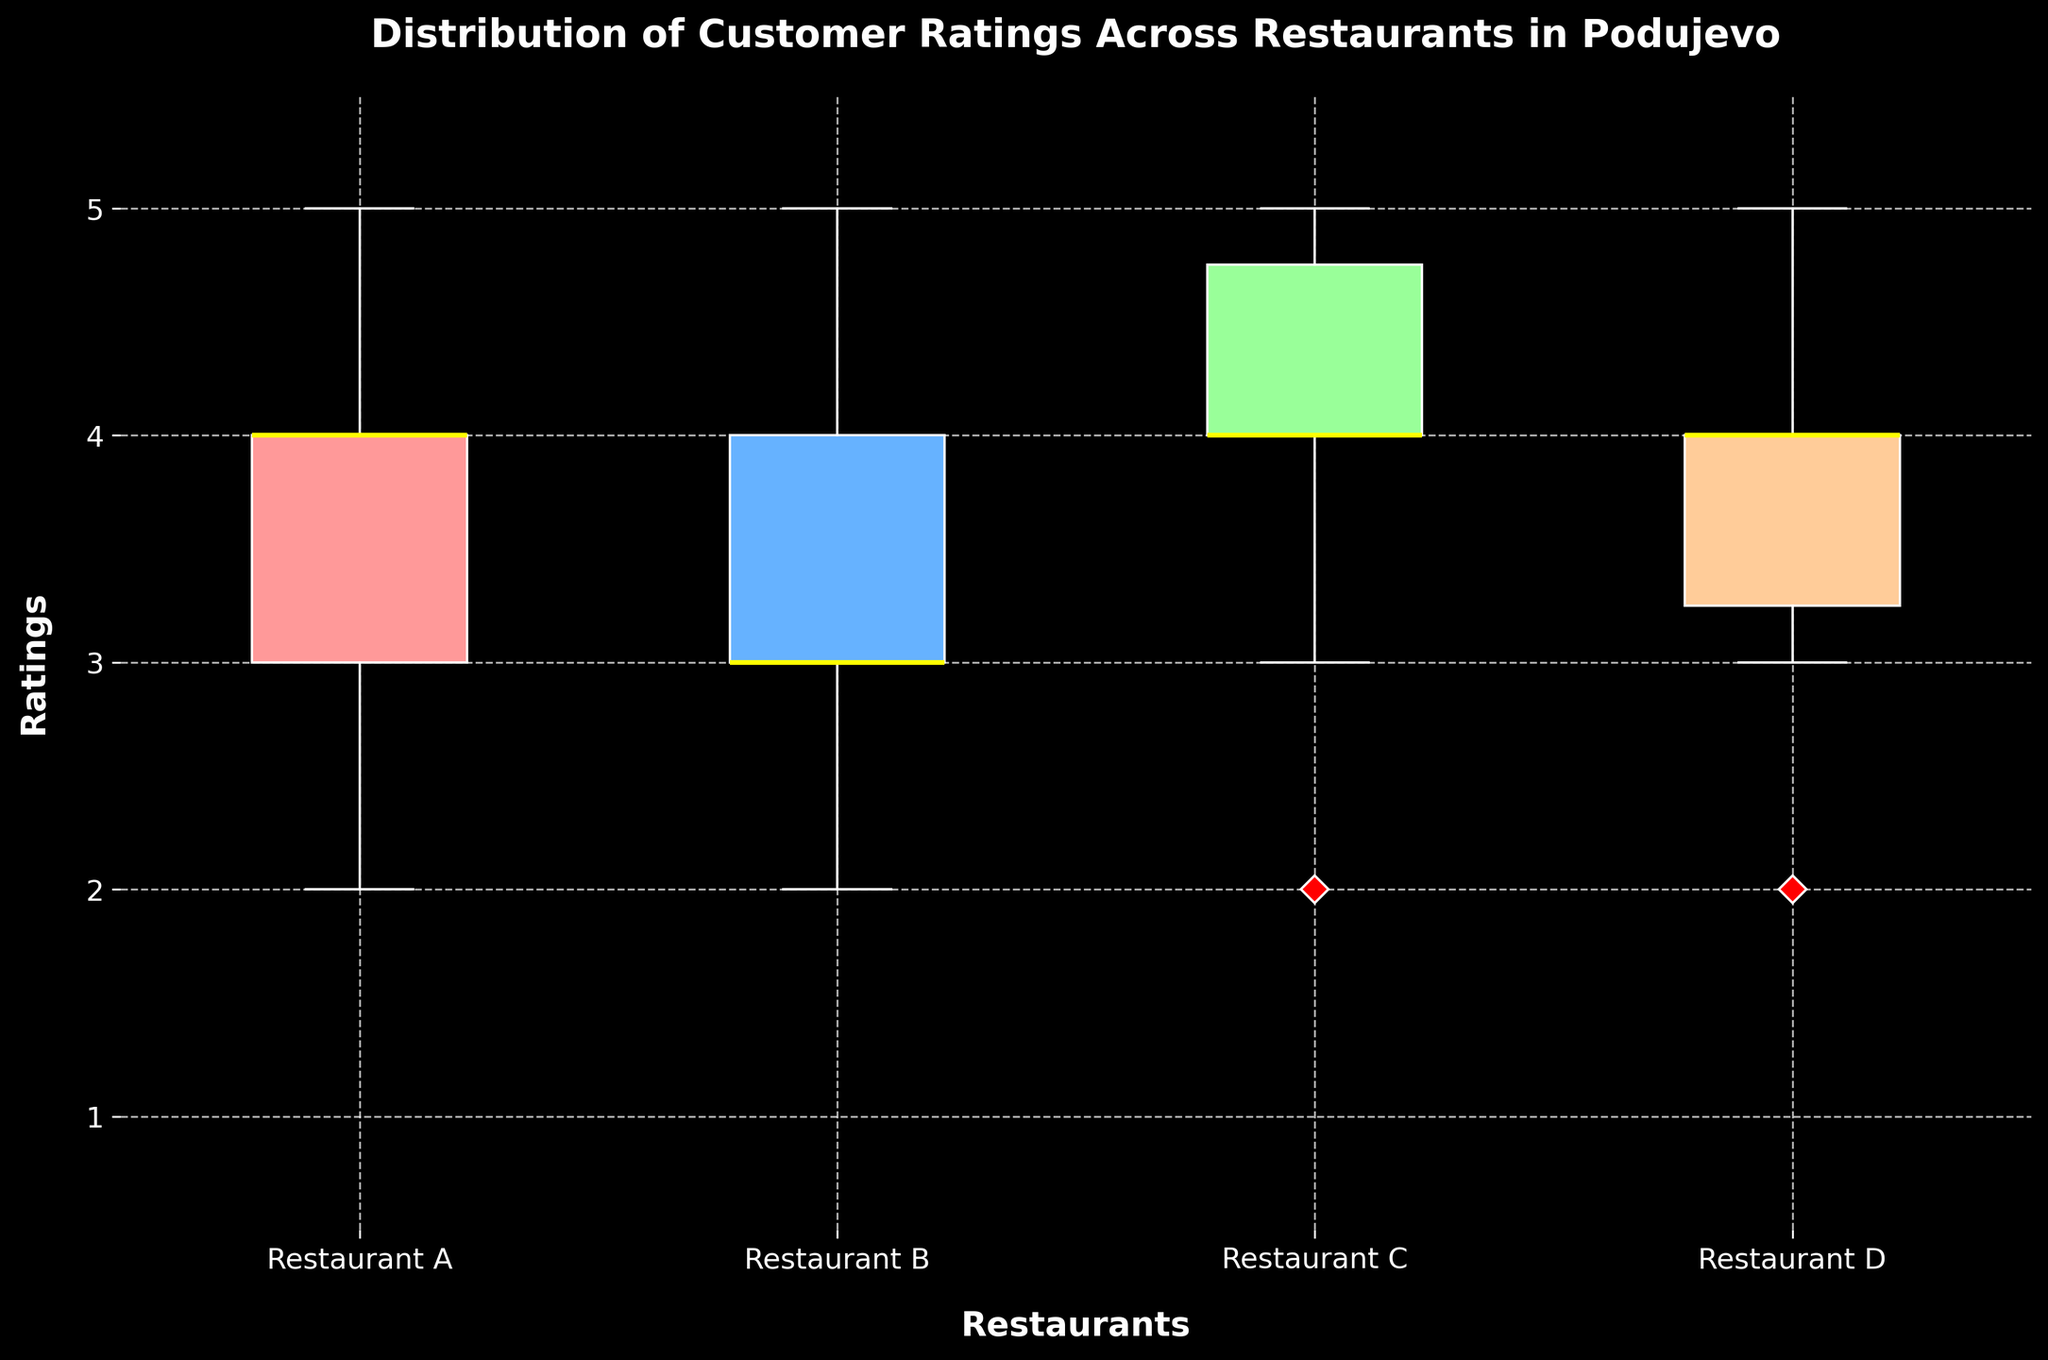What is the title of the plot? The title is found at the top of the plot and summarizes what the figure represents. The title given is 'Distribution of Customer Ratings Across Restaurants in Podujevo'.
Answer: Distribution of Customer Ratings Across Restaurants in Podujevo Which restaurant has the highest median rating? To identify the highest median rating, look for the restaurant with the median line (usually in the middle of the box) at the highest point. In this case, Restaurant C has the highest median rating.
Answer: Restaurant C What are the colors of the boxes in the plot? Each restaurant's box plot is colored differently. The colors used are light pink, light blue, light green, and light orange.
Answer: Light pink, light blue, light green, light orange What is the range of ratings for Restaurant D? The range of ratings for a box plot is given by the distance between the whiskers (minimum and maximum values). For Restaurant D, the ratings range from 2 to 5.
Answer: 2 to 5 Which restaurant shows the widest spread in ratings? The spread can be identified by looking at the length of the box between the first quartile and the third quartile plus the length of the whiskers. Restaurant A has the widest spread as the box and whiskers cover the largest range of values.
Answer: Restaurant A How many restaurants have an outlier rating, and what are they? Outliers are represented by points outside the whiskers. Only Restaurant C has an outlier in this plot.
Answer: 1, Restaurant C Which restaurant has the lowest minimum rating? The minimum rating for each restaurant can be found at the bottom whisker. Restaurant A, B, C, and D all have equal minimum ratings of 2.
Answer: Restaurant A, B, C, D If you were to recommend the restaurant with the most consistent ratings, which one would it be? Consistent ratings indicate a smaller spread in the box plot. Restaurant B shows very little spread, indicating consistency in ratings.
Answer: Restaurant B 